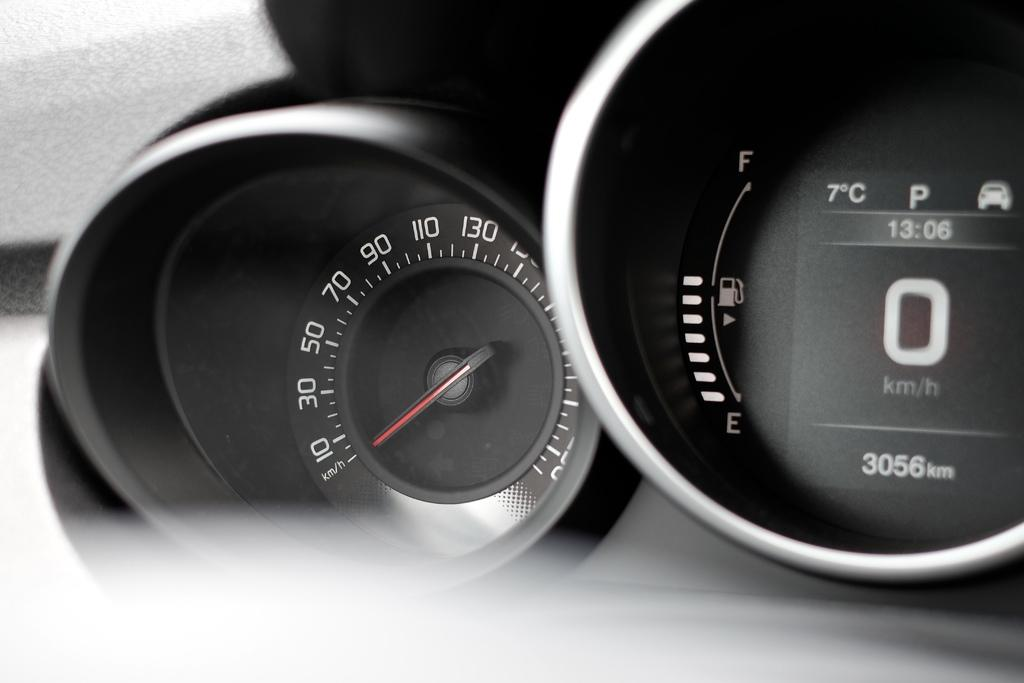What device is featured in the image? There is a speedometer in the image. Can you describe the background in the image? There is a background in the image, but its specific details are not mentioned in the provided facts. How would you characterize the clarity of the image? The bottom of the image is blurred. What type of string is tied around the speedometer in the image? There is no mention of a string in the provided facts, and therefore no such detail can be observed in the image. 